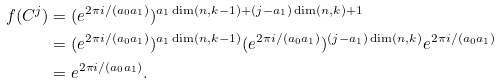Convert formula to latex. <formula><loc_0><loc_0><loc_500><loc_500>f ( C ^ { j } ) & = ( e ^ { 2 \pi i / ( a _ { 0 } a _ { 1 } ) } ) ^ { a _ { 1 } \dim ( n , k - 1 ) + ( j - a _ { 1 } ) \dim ( n , k ) + 1 } \\ & = ( e ^ { 2 \pi i / ( a _ { 0 } a _ { 1 } ) } ) ^ { a _ { 1 } \dim ( n , k - 1 ) } ( e ^ { 2 \pi i / ( a _ { 0 } a _ { 1 } ) } ) ^ { ( j - a _ { 1 } ) \dim ( n , k ) } e ^ { 2 \pi i / ( a _ { 0 } a _ { 1 } ) } \\ & = e ^ { 2 \pi i / ( a _ { 0 } a _ { 1 } ) } .</formula> 